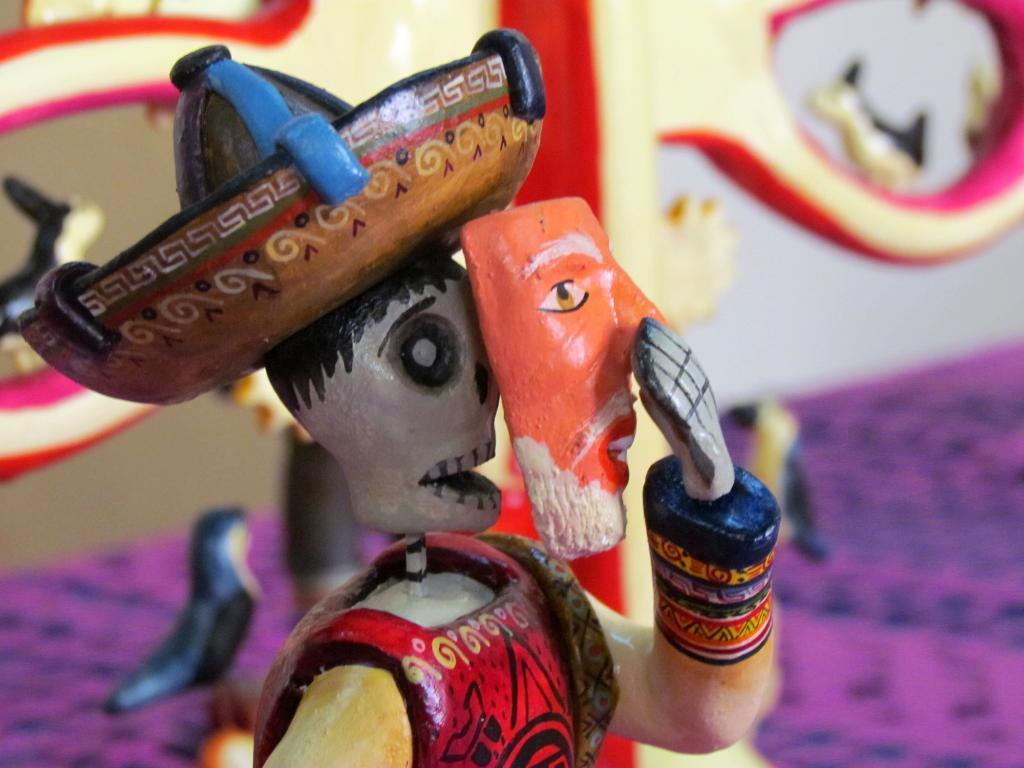What objects can be seen in the image? There are toys in the image. Can you describe the background of the image? The background of the image is blurry. What type of battle is taking place in the image? There is no battle present in the image; it features toys and a blurry background. Who is the expert in the image? There is no expert present in the image; it features toys and a blurry background. 